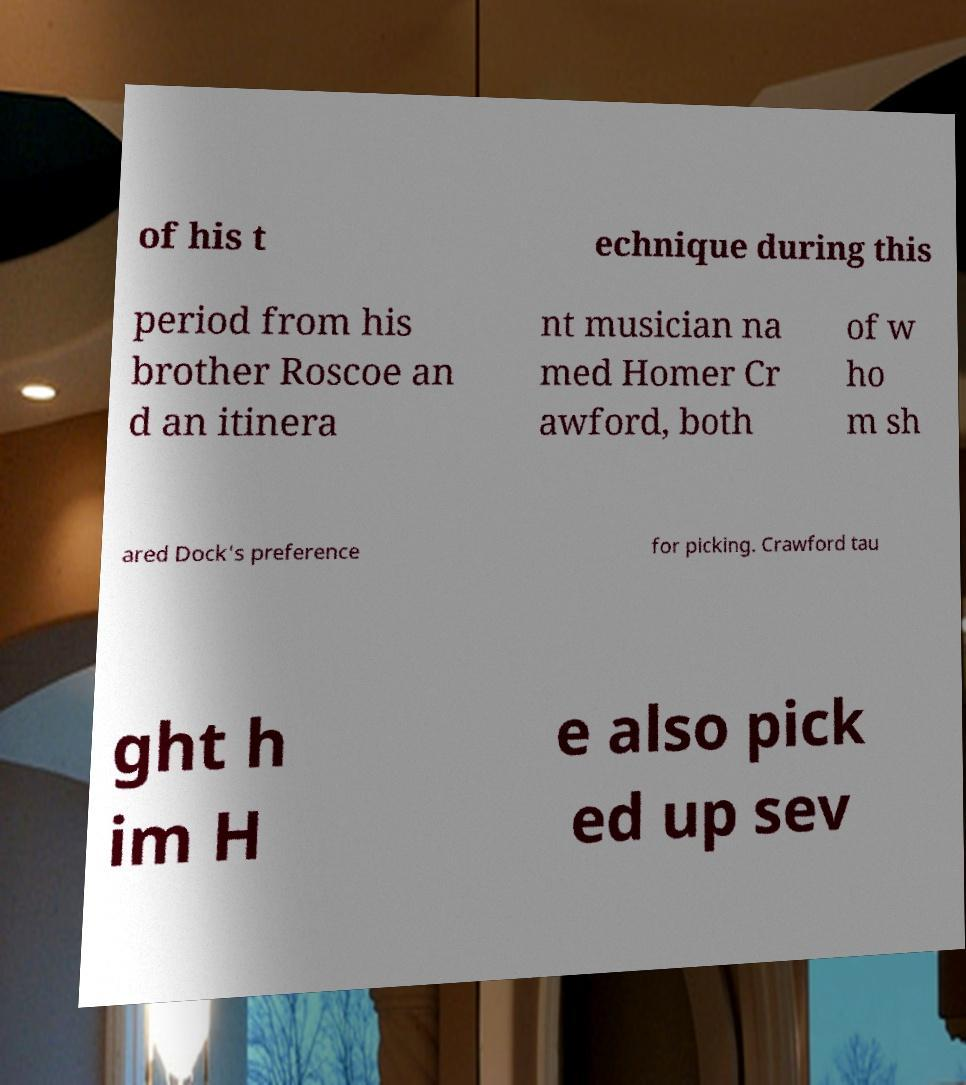Can you accurately transcribe the text from the provided image for me? of his t echnique during this period from his brother Roscoe an d an itinera nt musician na med Homer Cr awford, both of w ho m sh ared Dock's preference for picking. Crawford tau ght h im H e also pick ed up sev 